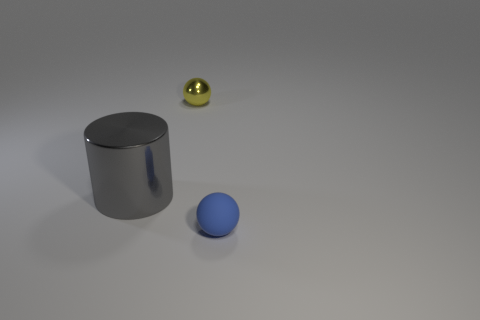Are there any other things that are the same size as the gray thing?
Your response must be concise. No. The tiny rubber ball has what color?
Offer a very short reply. Blue. What size is the gray object that is to the left of the matte object?
Give a very brief answer. Large. There is a sphere left of the tiny blue rubber ball that is in front of the big cylinder; what number of yellow metallic spheres are right of it?
Offer a terse response. 0. What is the color of the tiny thing behind the ball right of the metal ball?
Offer a terse response. Yellow. Is there a thing that has the same size as the blue ball?
Your answer should be very brief. Yes. There is a small object behind the shiny thing that is in front of the object behind the gray metallic cylinder; what is it made of?
Make the answer very short. Metal. There is a shiny ball behind the large object; what number of things are on the right side of it?
Your answer should be very brief. 1. There is a sphere that is behind the blue object; does it have the same size as the matte object?
Provide a succinct answer. Yes. What number of small yellow metal objects are the same shape as the blue rubber thing?
Give a very brief answer. 1. 